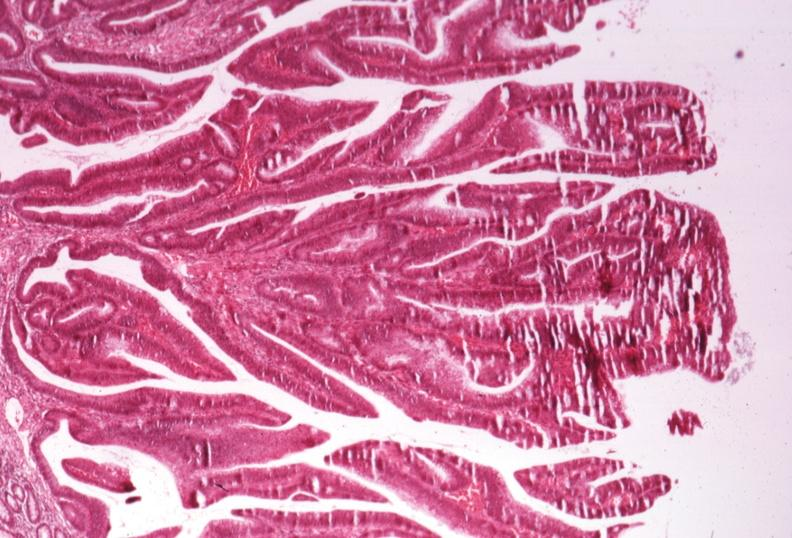where is this from?
Answer the question using a single word or phrase. Gastrointestinal system 